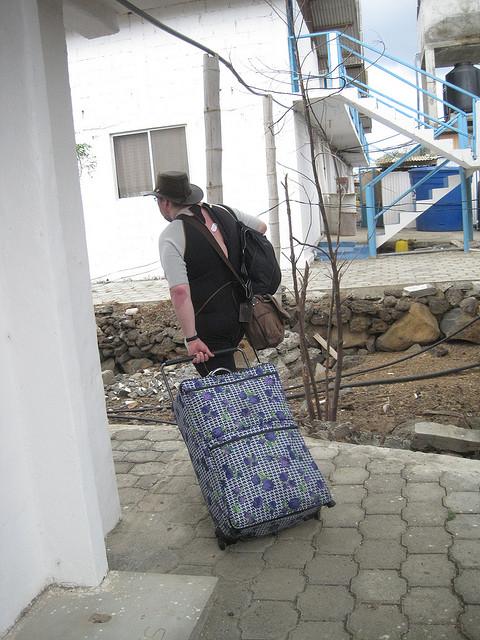Is the man coming or going?
Give a very brief answer. Going. What is the boy riding?
Keep it brief. Nothing. What does man have in his left hand?
Be succinct. Suitcase. Is he going on a trip?
Keep it brief. Yes. 